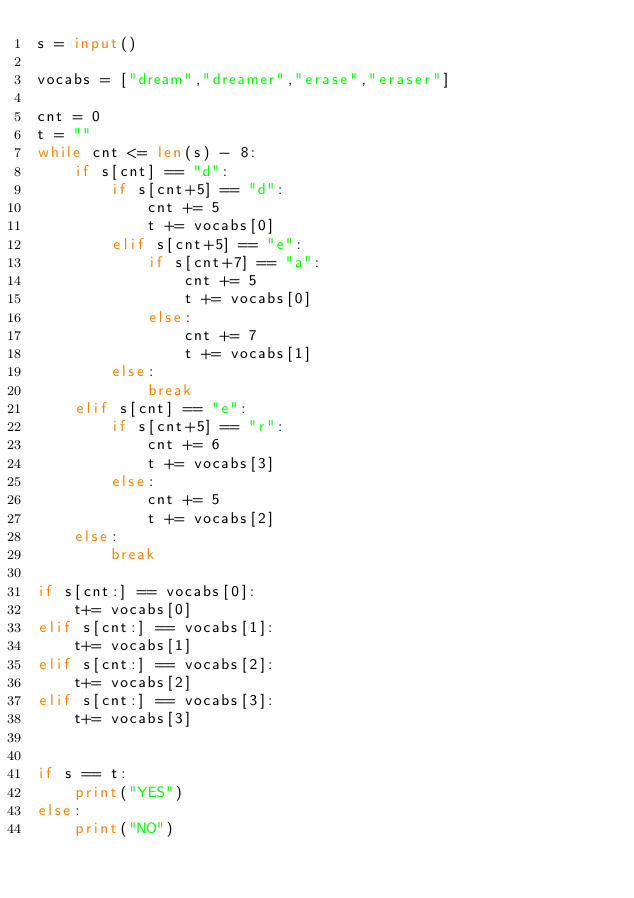<code> <loc_0><loc_0><loc_500><loc_500><_Python_>s = input()

vocabs = ["dream","dreamer","erase","eraser"]

cnt = 0
t = ""
while cnt <= len(s) - 8:
    if s[cnt] == "d":
        if s[cnt+5] == "d":
            cnt += 5
            t += vocabs[0]
        elif s[cnt+5] == "e":
            if s[cnt+7] == "a":
                cnt += 5
                t += vocabs[0]
            else:
                cnt += 7
                t += vocabs[1]
        else:
            break
    elif s[cnt] == "e":
        if s[cnt+5] == "r":
            cnt += 6
            t += vocabs[3]
        else:
            cnt += 5
            t += vocabs[2]
    else:
        break

if s[cnt:] == vocabs[0]:
    t+= vocabs[0]
elif s[cnt:] == vocabs[1]:
    t+= vocabs[1]
elif s[cnt:] == vocabs[2]:
    t+= vocabs[2]
elif s[cnt:] == vocabs[3]:
    t+= vocabs[3]


if s == t:
    print("YES")
else:
    print("NO")</code> 